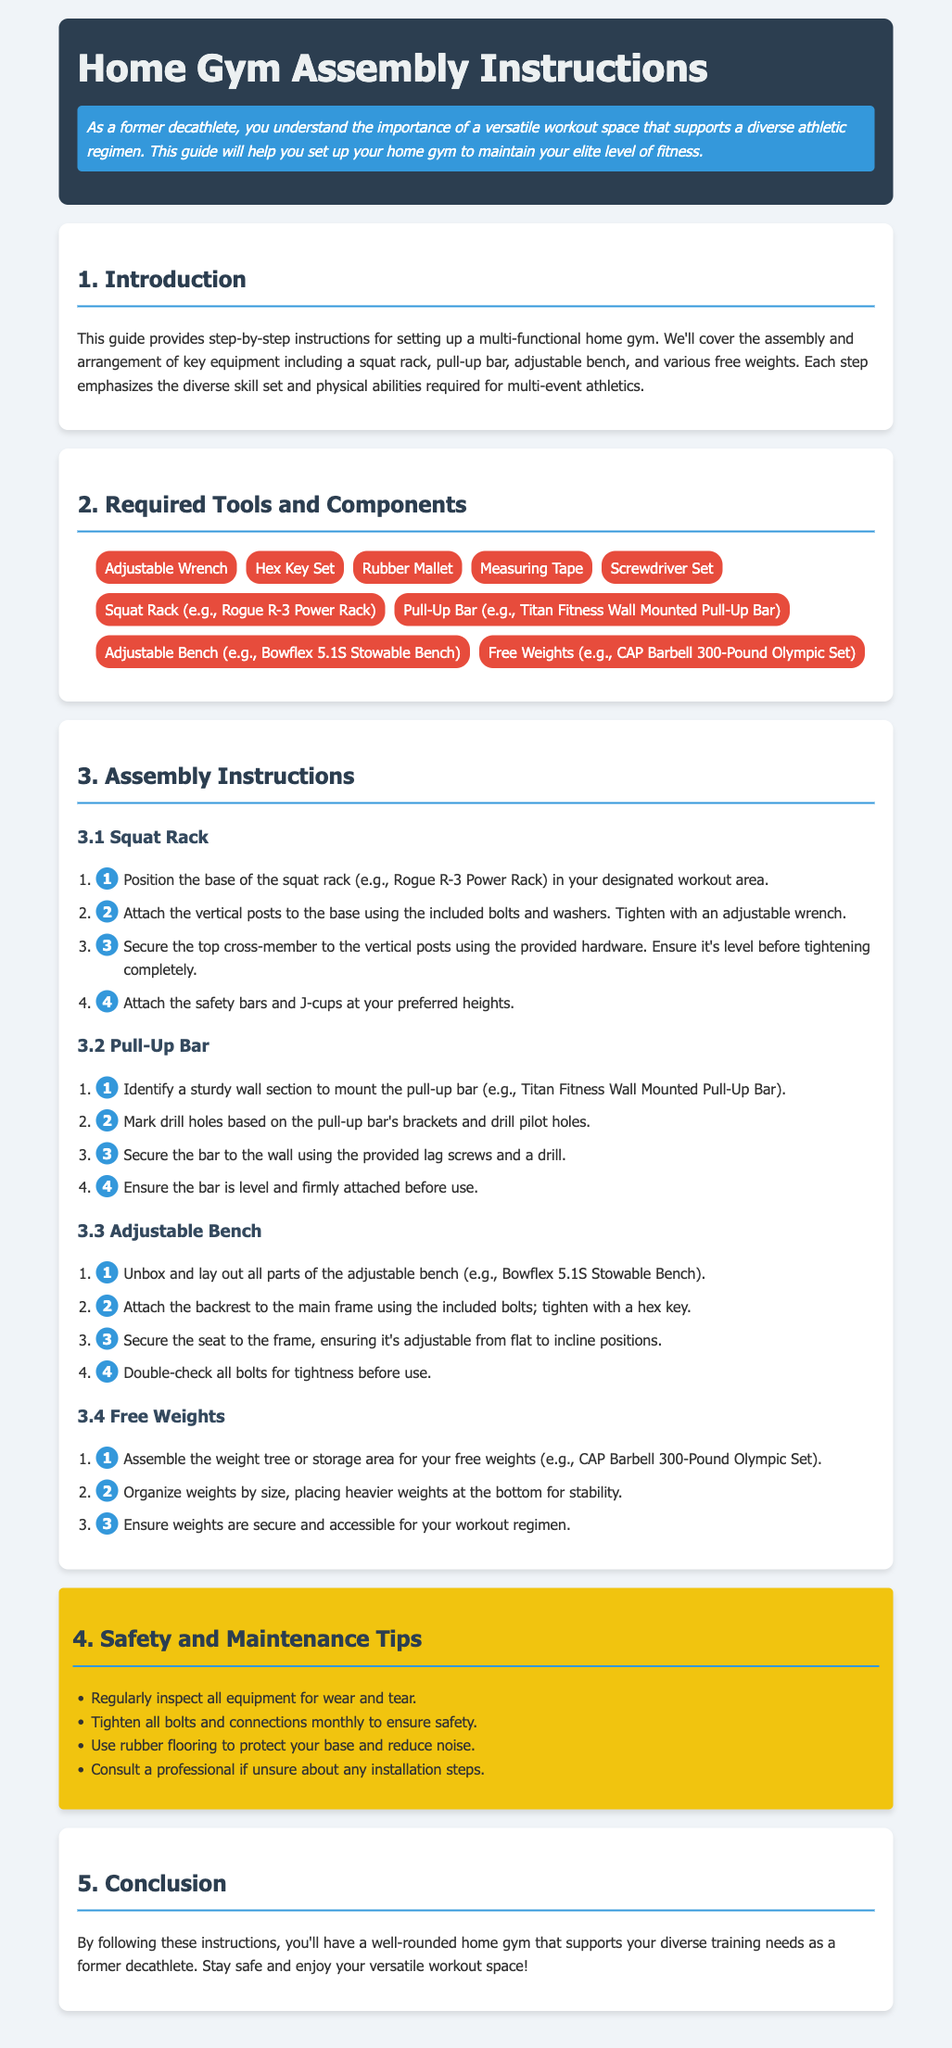What type of gym equipment is mentioned for assembly? The document lists specific equipment such as a squat rack, pull-up bar, adjustable bench, and various free weights for assembly.
Answer: squat rack, pull-up bar, adjustable bench, free weights What is the first step for assembling the squat rack? The first step for assembling the squat rack involves positioning the base of the squat rack in your designated workout area.
Answer: Position the base How many tools are listed in the required tools section? The document provides a list of tools required for assembly, totaling six.
Answer: 6 Which equipment is specified as the "Bowflex 5.1S Stowable Bench"? The adjustable bench is identified as the Bowflex 5.1S Stowable Bench within the instructions.
Answer: Adjustable Bench What should you do if unsure about any installation steps? The document advises consulting a professional if you're unsure about any installation steps.
Answer: Consult a professional What color is used for the safety and maintenance tips section? The safety and maintenance tips section is presented in a yellow background color to stand out in the document.
Answer: Yellow Which section provides information on how to mount the pull-up bar? The section detailing the assembly of the pull-up bar includes step-by-step instructions for its installation.
Answer: Pull-Up Bar What should you do monthly for safety assurance? The document suggests tightening all bolts and connections monthly to ensure safety.
Answer: Tighten all bolts 